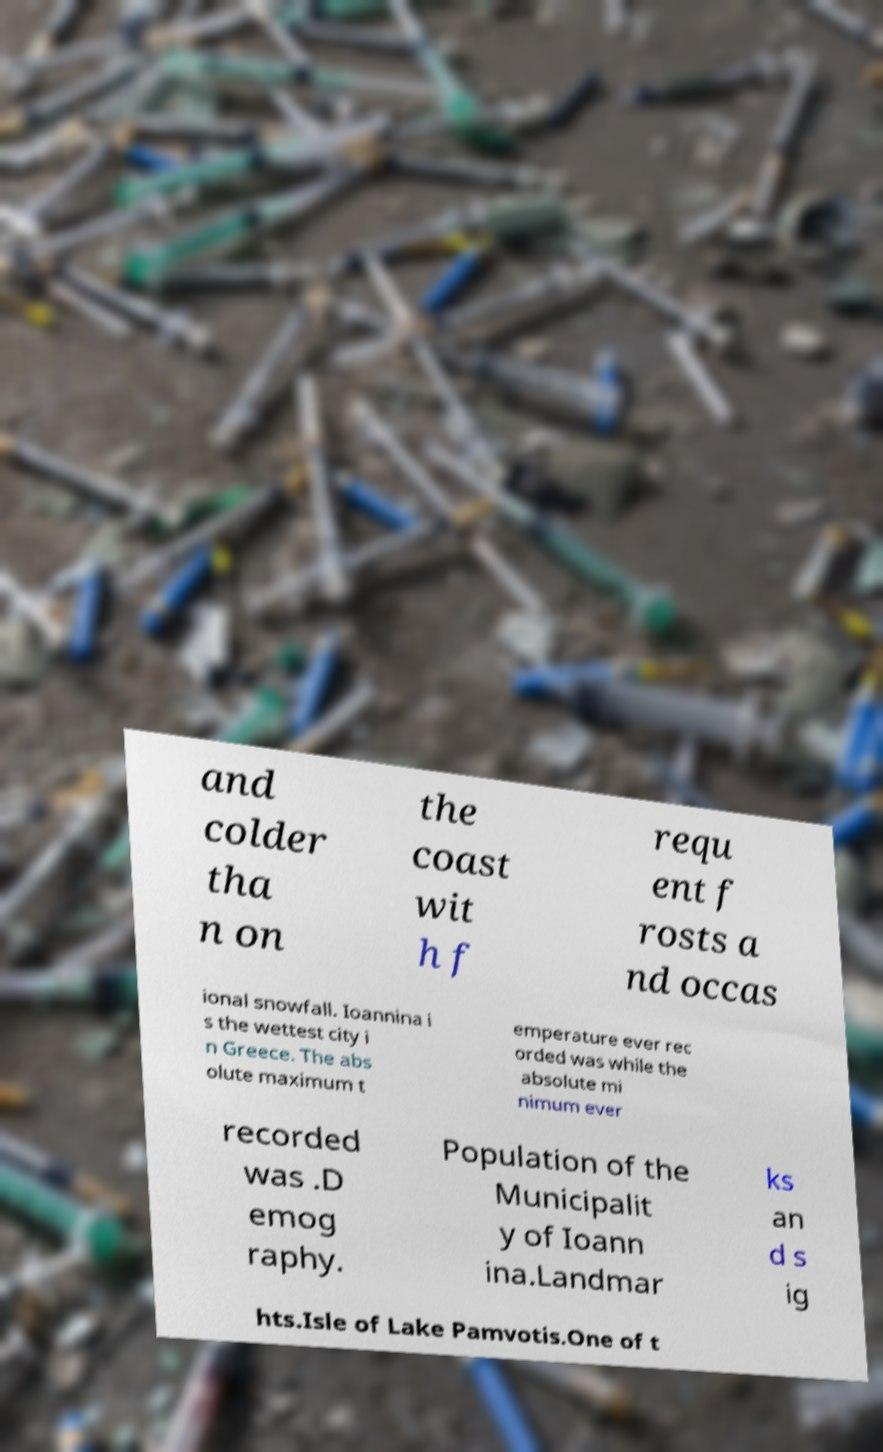I need the written content from this picture converted into text. Can you do that? and colder tha n on the coast wit h f requ ent f rosts a nd occas ional snowfall. Ioannina i s the wettest city i n Greece. The abs olute maximum t emperature ever rec orded was while the absolute mi nimum ever recorded was .D emog raphy. Population of the Municipalit y of Ioann ina.Landmar ks an d s ig hts.Isle of Lake Pamvotis.One of t 